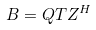<formula> <loc_0><loc_0><loc_500><loc_500>B = Q T Z ^ { H }</formula> 